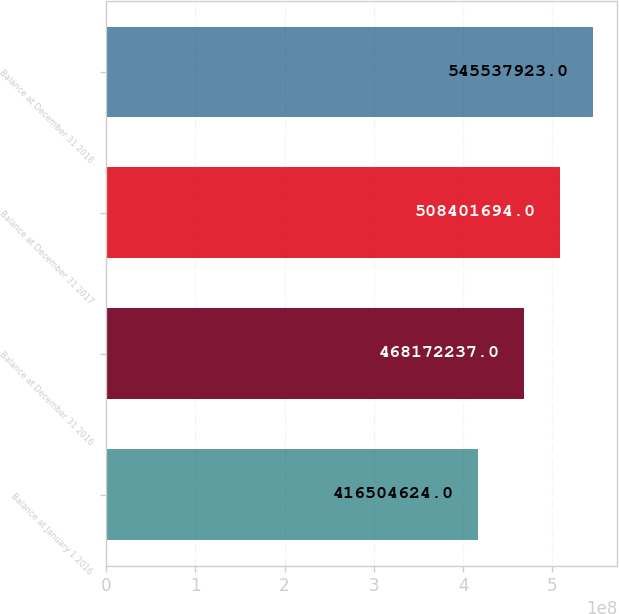Convert chart to OTSL. <chart><loc_0><loc_0><loc_500><loc_500><bar_chart><fcel>Balance at January 1 2016<fcel>Balance at December 31 2016<fcel>Balance at December 31 2017<fcel>Balance at December 31 2018<nl><fcel>4.16505e+08<fcel>4.68172e+08<fcel>5.08402e+08<fcel>5.45538e+08<nl></chart> 